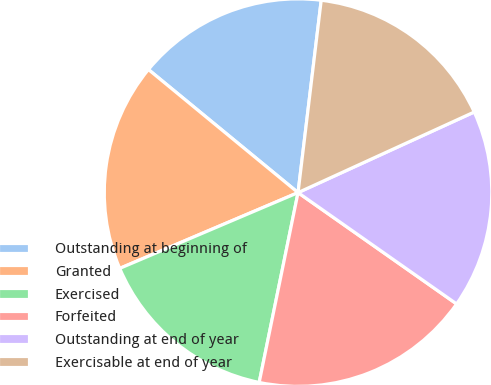Convert chart. <chart><loc_0><loc_0><loc_500><loc_500><pie_chart><fcel>Outstanding at beginning of<fcel>Granted<fcel>Exercised<fcel>Forfeited<fcel>Outstanding at end of year<fcel>Exercisable at end of year<nl><fcel>15.95%<fcel>17.35%<fcel>15.39%<fcel>18.47%<fcel>16.57%<fcel>16.26%<nl></chart> 